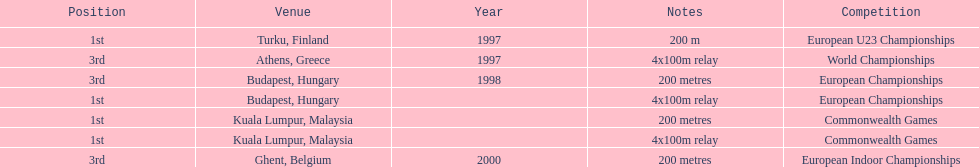How many total years did golding compete? 3. 